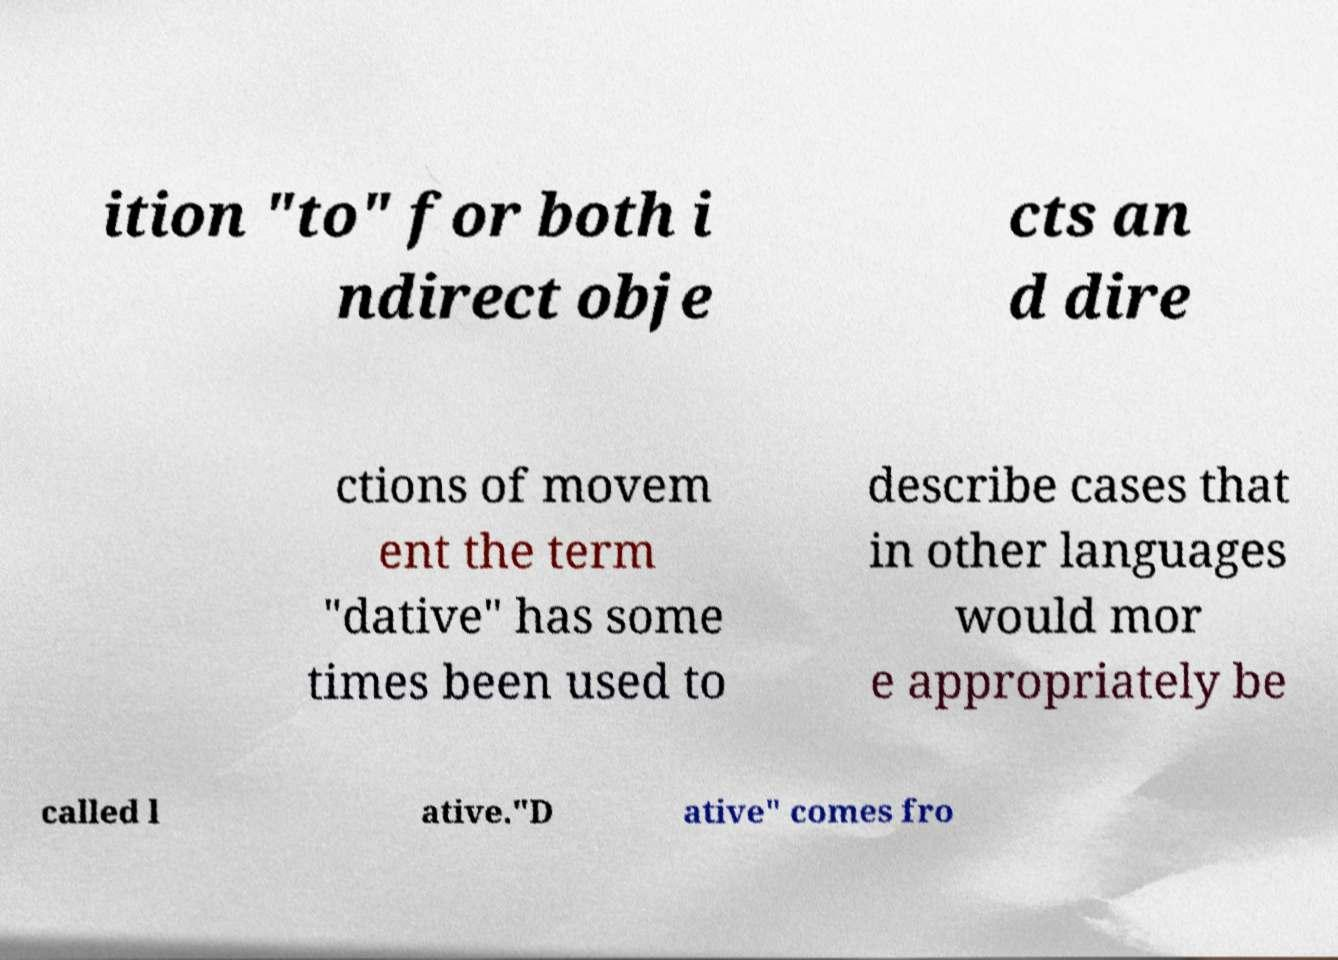Please read and relay the text visible in this image. What does it say? ition "to" for both i ndirect obje cts an d dire ctions of movem ent the term "dative" has some times been used to describe cases that in other languages would mor e appropriately be called l ative."D ative" comes fro 